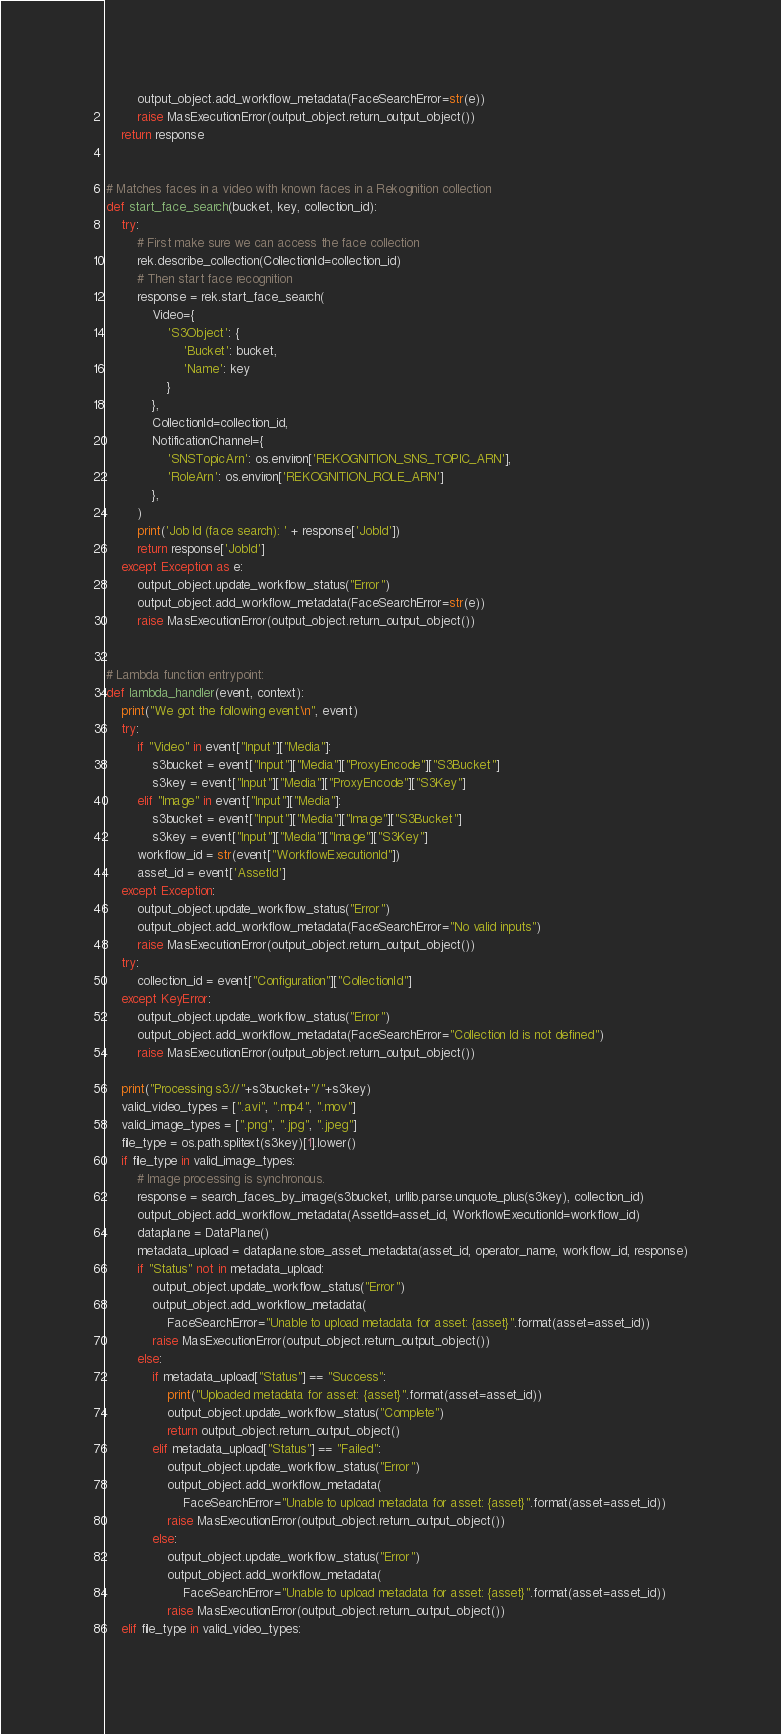<code> <loc_0><loc_0><loc_500><loc_500><_Python_>        output_object.add_workflow_metadata(FaceSearchError=str(e))
        raise MasExecutionError(output_object.return_output_object())
    return response


# Matches faces in a video with known faces in a Rekognition collection
def start_face_search(bucket, key, collection_id):
    try:
        # First make sure we can access the face collection
        rek.describe_collection(CollectionId=collection_id)
        # Then start face recognition
        response = rek.start_face_search(
            Video={
                'S3Object': {
                    'Bucket': bucket,
                    'Name': key
                }
            },
            CollectionId=collection_id,
            NotificationChannel={
                'SNSTopicArn': os.environ['REKOGNITION_SNS_TOPIC_ARN'],
                'RoleArn': os.environ['REKOGNITION_ROLE_ARN']
            },
        )
        print('Job Id (face search): ' + response['JobId'])
        return response['JobId']
    except Exception as e:
        output_object.update_workflow_status("Error")
        output_object.add_workflow_metadata(FaceSearchError=str(e))
        raise MasExecutionError(output_object.return_output_object())


# Lambda function entrypoint:
def lambda_handler(event, context):
    print("We got the following event:\n", event)
    try:
        if "Video" in event["Input"]["Media"]:
            s3bucket = event["Input"]["Media"]["ProxyEncode"]["S3Bucket"]
            s3key = event["Input"]["Media"]["ProxyEncode"]["S3Key"]
        elif "Image" in event["Input"]["Media"]:
            s3bucket = event["Input"]["Media"]["Image"]["S3Bucket"]
            s3key = event["Input"]["Media"]["Image"]["S3Key"]
        workflow_id = str(event["WorkflowExecutionId"])
        asset_id = event['AssetId']
    except Exception:
        output_object.update_workflow_status("Error")
        output_object.add_workflow_metadata(FaceSearchError="No valid inputs")
        raise MasExecutionError(output_object.return_output_object())
    try:
        collection_id = event["Configuration"]["CollectionId"]
    except KeyError:
        output_object.update_workflow_status("Error")
        output_object.add_workflow_metadata(FaceSearchError="Collection Id is not defined")
        raise MasExecutionError(output_object.return_output_object())

    print("Processing s3://"+s3bucket+"/"+s3key)
    valid_video_types = [".avi", ".mp4", ".mov"]
    valid_image_types = [".png", ".jpg", ".jpeg"]
    file_type = os.path.splitext(s3key)[1].lower()
    if file_type in valid_image_types:
        # Image processing is synchronous.
        response = search_faces_by_image(s3bucket, urllib.parse.unquote_plus(s3key), collection_id)
        output_object.add_workflow_metadata(AssetId=asset_id, WorkflowExecutionId=workflow_id)
        dataplane = DataPlane()
        metadata_upload = dataplane.store_asset_metadata(asset_id, operator_name, workflow_id, response)
        if "Status" not in metadata_upload:
            output_object.update_workflow_status("Error")
            output_object.add_workflow_metadata(
                FaceSearchError="Unable to upload metadata for asset: {asset}".format(asset=asset_id))
            raise MasExecutionError(output_object.return_output_object())
        else:
            if metadata_upload["Status"] == "Success":
                print("Uploaded metadata for asset: {asset}".format(asset=asset_id))
                output_object.update_workflow_status("Complete")
                return output_object.return_output_object()
            elif metadata_upload["Status"] == "Failed":
                output_object.update_workflow_status("Error")
                output_object.add_workflow_metadata(
                    FaceSearchError="Unable to upload metadata for asset: {asset}".format(asset=asset_id))
                raise MasExecutionError(output_object.return_output_object())
            else:
                output_object.update_workflow_status("Error")
                output_object.add_workflow_metadata(
                    FaceSearchError="Unable to upload metadata for asset: {asset}".format(asset=asset_id))
                raise MasExecutionError(output_object.return_output_object())
    elif file_type in valid_video_types:</code> 